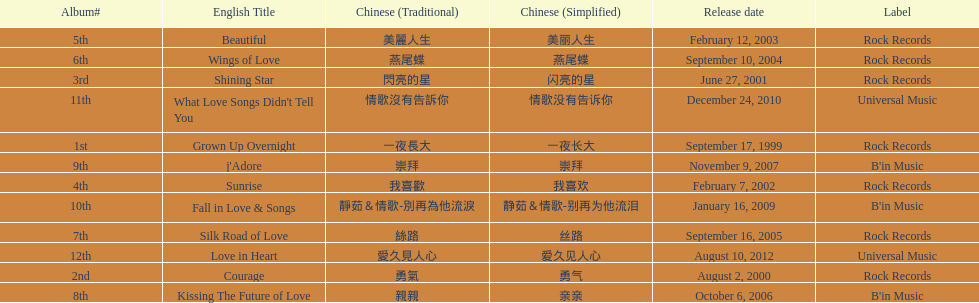What is the number of songs on rock records? 7. 